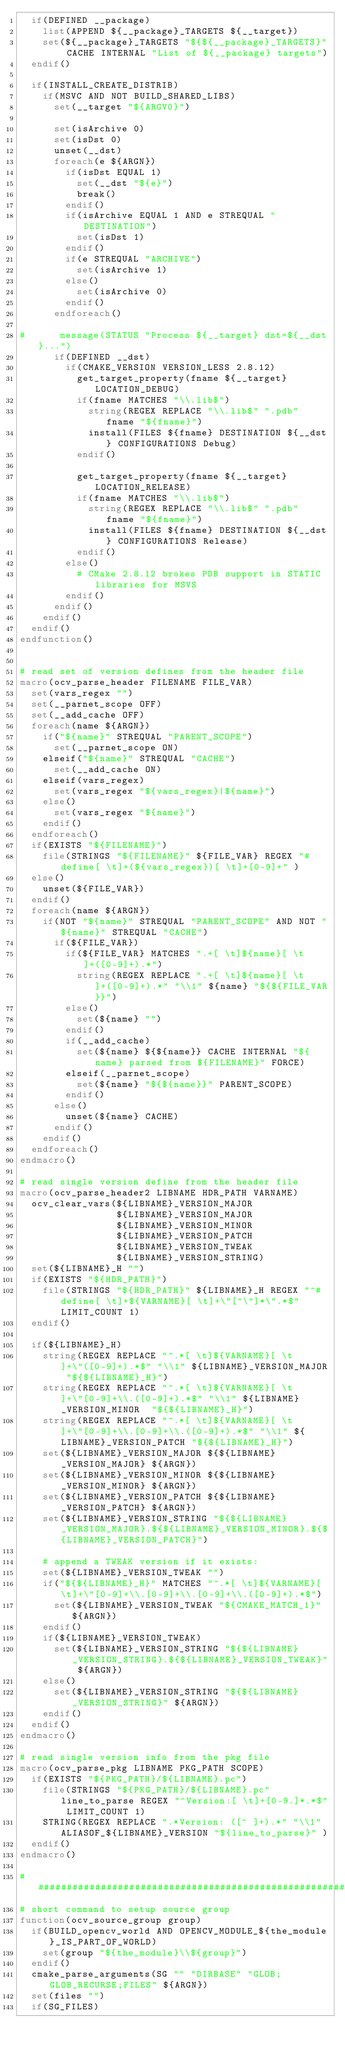<code> <loc_0><loc_0><loc_500><loc_500><_CMake_>  if(DEFINED __package)
    list(APPEND ${__package}_TARGETS ${__target})
    set(${__package}_TARGETS "${${__package}_TARGETS}" CACHE INTERNAL "List of ${__package} targets")
  endif()

  if(INSTALL_CREATE_DISTRIB)
    if(MSVC AND NOT BUILD_SHARED_LIBS)
      set(__target "${ARGV0}")

      set(isArchive 0)
      set(isDst 0)
      unset(__dst)
      foreach(e ${ARGN})
        if(isDst EQUAL 1)
          set(__dst "${e}")
          break()
        endif()
        if(isArchive EQUAL 1 AND e STREQUAL "DESTINATION")
          set(isDst 1)
        endif()
        if(e STREQUAL "ARCHIVE")
          set(isArchive 1)
        else()
          set(isArchive 0)
        endif()
      endforeach()

#      message(STATUS "Process ${__target} dst=${__dst}...")
      if(DEFINED __dst)
        if(CMAKE_VERSION VERSION_LESS 2.8.12)
          get_target_property(fname ${__target} LOCATION_DEBUG)
          if(fname MATCHES "\\.lib$")
            string(REGEX REPLACE "\\.lib$" ".pdb" fname "${fname}")
            install(FILES ${fname} DESTINATION ${__dst} CONFIGURATIONS Debug)
          endif()

          get_target_property(fname ${__target} LOCATION_RELEASE)
          if(fname MATCHES "\\.lib$")
            string(REGEX REPLACE "\\.lib$" ".pdb" fname "${fname}")
            install(FILES ${fname} DESTINATION ${__dst} CONFIGURATIONS Release)
          endif()
        else()
          # CMake 2.8.12 brokes PDB support in STATIC libraries for MSVS
        endif()
      endif()
    endif()
  endif()
endfunction()


# read set of version defines from the header file
macro(ocv_parse_header FILENAME FILE_VAR)
  set(vars_regex "")
  set(__parnet_scope OFF)
  set(__add_cache OFF)
  foreach(name ${ARGN})
    if("${name}" STREQUAL "PARENT_SCOPE")
      set(__parnet_scope ON)
    elseif("${name}" STREQUAL "CACHE")
      set(__add_cache ON)
    elseif(vars_regex)
      set(vars_regex "${vars_regex}|${name}")
    else()
      set(vars_regex "${name}")
    endif()
  endforeach()
  if(EXISTS "${FILENAME}")
    file(STRINGS "${FILENAME}" ${FILE_VAR} REGEX "#define[ \t]+(${vars_regex})[ \t]+[0-9]+" )
  else()
    unset(${FILE_VAR})
  endif()
  foreach(name ${ARGN})
    if(NOT "${name}" STREQUAL "PARENT_SCOPE" AND NOT "${name}" STREQUAL "CACHE")
      if(${FILE_VAR})
        if(${FILE_VAR} MATCHES ".+[ \t]${name}[ \t]+([0-9]+).*")
          string(REGEX REPLACE ".+[ \t]${name}[ \t]+([0-9]+).*" "\\1" ${name} "${${FILE_VAR}}")
        else()
          set(${name} "")
        endif()
        if(__add_cache)
          set(${name} ${${name}} CACHE INTERNAL "${name} parsed from ${FILENAME}" FORCE)
        elseif(__parnet_scope)
          set(${name} "${${name}}" PARENT_SCOPE)
        endif()
      else()
        unset(${name} CACHE)
      endif()
    endif()
  endforeach()
endmacro()

# read single version define from the header file
macro(ocv_parse_header2 LIBNAME HDR_PATH VARNAME)
  ocv_clear_vars(${LIBNAME}_VERSION_MAJOR
                 ${LIBNAME}_VERSION_MAJOR
                 ${LIBNAME}_VERSION_MINOR
                 ${LIBNAME}_VERSION_PATCH
                 ${LIBNAME}_VERSION_TWEAK
                 ${LIBNAME}_VERSION_STRING)
  set(${LIBNAME}_H "")
  if(EXISTS "${HDR_PATH}")
    file(STRINGS "${HDR_PATH}" ${LIBNAME}_H REGEX "^#define[ \t]+${VARNAME}[ \t]+\"[^\"]*\".*$" LIMIT_COUNT 1)
  endif()

  if(${LIBNAME}_H)
    string(REGEX REPLACE "^.*[ \t]${VARNAME}[ \t]+\"([0-9]+).*$" "\\1" ${LIBNAME}_VERSION_MAJOR "${${LIBNAME}_H}")
    string(REGEX REPLACE "^.*[ \t]${VARNAME}[ \t]+\"[0-9]+\\.([0-9]+).*$" "\\1" ${LIBNAME}_VERSION_MINOR  "${${LIBNAME}_H}")
    string(REGEX REPLACE "^.*[ \t]${VARNAME}[ \t]+\"[0-9]+\\.[0-9]+\\.([0-9]+).*$" "\\1" ${LIBNAME}_VERSION_PATCH "${${LIBNAME}_H}")
    set(${LIBNAME}_VERSION_MAJOR ${${LIBNAME}_VERSION_MAJOR} ${ARGN})
    set(${LIBNAME}_VERSION_MINOR ${${LIBNAME}_VERSION_MINOR} ${ARGN})
    set(${LIBNAME}_VERSION_PATCH ${${LIBNAME}_VERSION_PATCH} ${ARGN})
    set(${LIBNAME}_VERSION_STRING "${${LIBNAME}_VERSION_MAJOR}.${${LIBNAME}_VERSION_MINOR}.${${LIBNAME}_VERSION_PATCH}")

    # append a TWEAK version if it exists:
    set(${LIBNAME}_VERSION_TWEAK "")
    if("${${LIBNAME}_H}" MATCHES "^.*[ \t]${VARNAME}[ \t]+\"[0-9]+\\.[0-9]+\\.[0-9]+\\.([0-9]+).*$")
      set(${LIBNAME}_VERSION_TWEAK "${CMAKE_MATCH_1}" ${ARGN})
    endif()
    if(${LIBNAME}_VERSION_TWEAK)
      set(${LIBNAME}_VERSION_STRING "${${LIBNAME}_VERSION_STRING}.${${LIBNAME}_VERSION_TWEAK}" ${ARGN})
    else()
      set(${LIBNAME}_VERSION_STRING "${${LIBNAME}_VERSION_STRING}" ${ARGN})
    endif()
  endif()
endmacro()

# read single version info from the pkg file
macro(ocv_parse_pkg LIBNAME PKG_PATH SCOPE)
  if(EXISTS "${PKG_PATH}/${LIBNAME}.pc")
    file(STRINGS "${PKG_PATH}/${LIBNAME}.pc" line_to_parse REGEX "^Version:[ \t]+[0-9.]*.*$" LIMIT_COUNT 1)
    STRING(REGEX REPLACE ".*Version: ([^ ]+).*" "\\1" ALIASOF_${LIBNAME}_VERSION "${line_to_parse}" )
  endif()
endmacro()

################################################################################################
# short command to setup source group
function(ocv_source_group group)
  if(BUILD_opencv_world AND OPENCV_MODULE_${the_module}_IS_PART_OF_WORLD)
    set(group "${the_module}\\${group}")
  endif()
  cmake_parse_arguments(SG "" "DIRBASE" "GLOB;GLOB_RECURSE;FILES" ${ARGN})
  set(files "")
  if(SG_FILES)</code> 